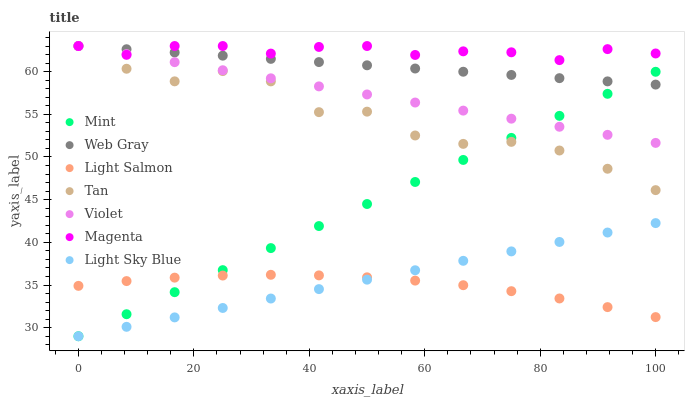Does Light Salmon have the minimum area under the curve?
Answer yes or no. Yes. Does Magenta have the maximum area under the curve?
Answer yes or no. Yes. Does Web Gray have the minimum area under the curve?
Answer yes or no. No. Does Web Gray have the maximum area under the curve?
Answer yes or no. No. Is Web Gray the smoothest?
Answer yes or no. Yes. Is Tan the roughest?
Answer yes or no. Yes. Is Light Sky Blue the smoothest?
Answer yes or no. No. Is Light Sky Blue the roughest?
Answer yes or no. No. Does Light Sky Blue have the lowest value?
Answer yes or no. Yes. Does Web Gray have the lowest value?
Answer yes or no. No. Does Magenta have the highest value?
Answer yes or no. Yes. Does Light Sky Blue have the highest value?
Answer yes or no. No. Is Mint less than Magenta?
Answer yes or no. Yes. Is Magenta greater than Light Salmon?
Answer yes or no. Yes. Does Tan intersect Mint?
Answer yes or no. Yes. Is Tan less than Mint?
Answer yes or no. No. Is Tan greater than Mint?
Answer yes or no. No. Does Mint intersect Magenta?
Answer yes or no. No. 